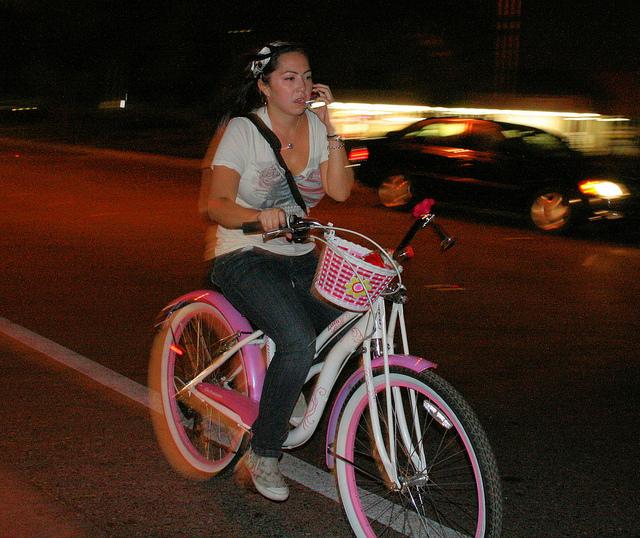Is she talking on her cell phone?
Quick response, please. Yes. What color is her shirt?
Write a very short answer. White. What is riding the bicycle?
Keep it brief. Woman. Are there training wheels?
Quick response, please. No. What type of shoe is this lady wearing?
Concise answer only. Sneaker. Is this her brother's bike?
Give a very brief answer. No. Which bike is the basket on?
Write a very short answer. Pink bike. Is the girl dressed for carnival?
Answer briefly. No. Does this bicycle have a basket?
Concise answer only. Yes. 